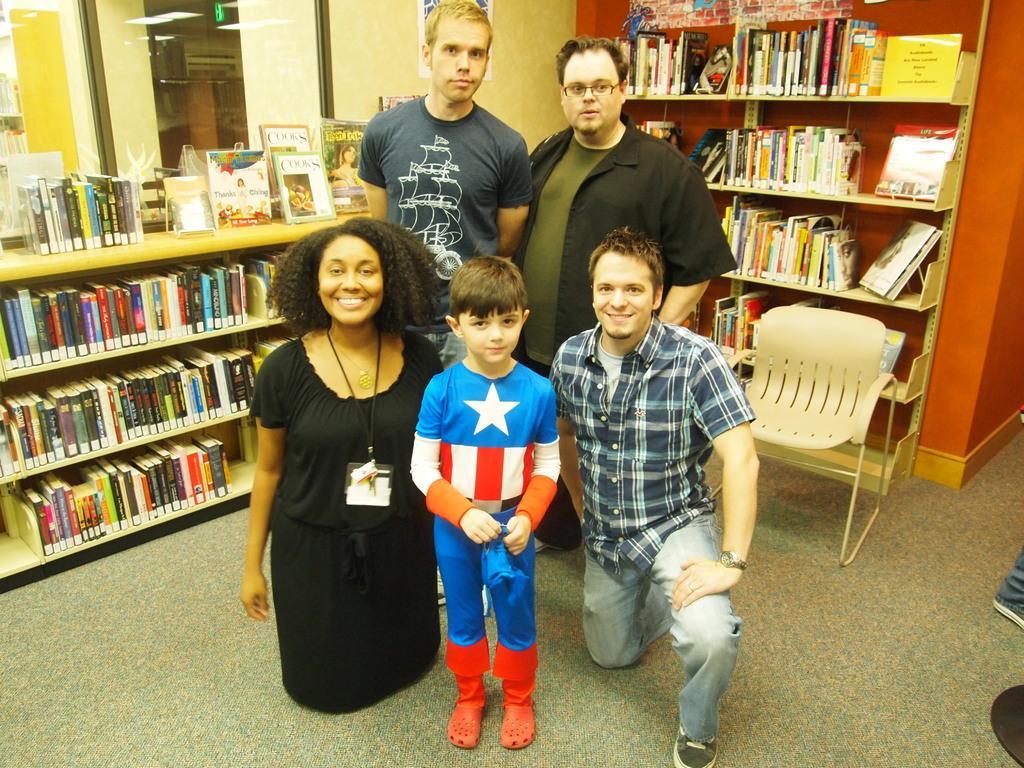Can you describe this image briefly? In this image we can see a group of people standing on the floor. One boy is wearing a costume. To the right side of the image we can see a chair placed on the ground. In the background, we can see group of books placed on racks, photo frame on the wall and some lights. 